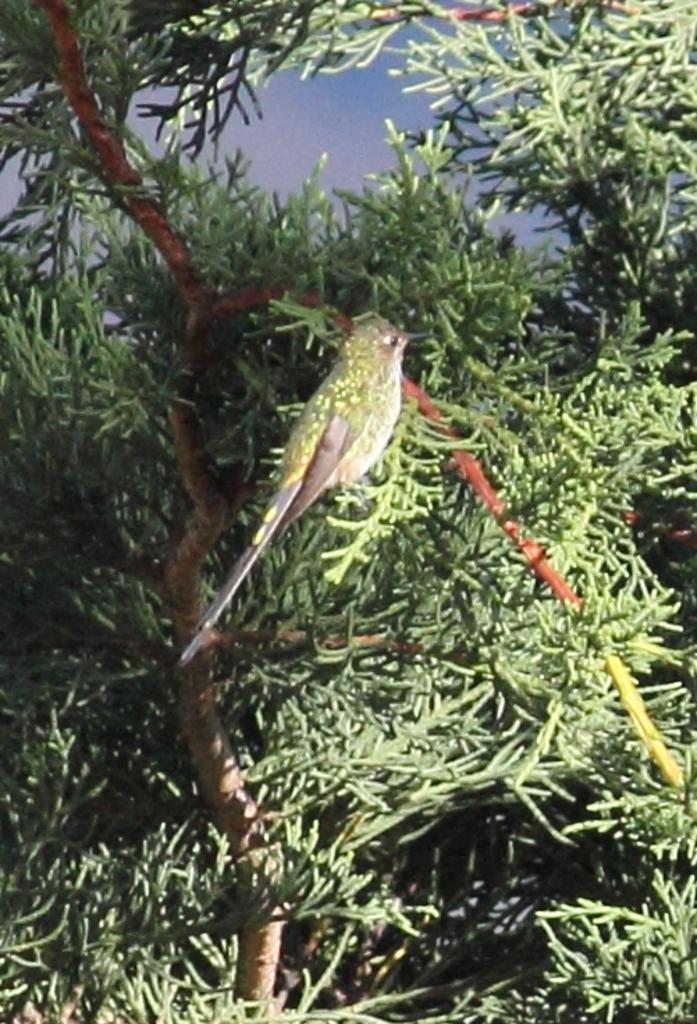What is the main subject in the center of the image? There is a bird in the center of the image. What can be seen in the background of the image? There are trees and the sky visible in the background of the image. What time of day is it at the seashore in the image? There is no seashore present in the image; it features a bird and trees in the background. 